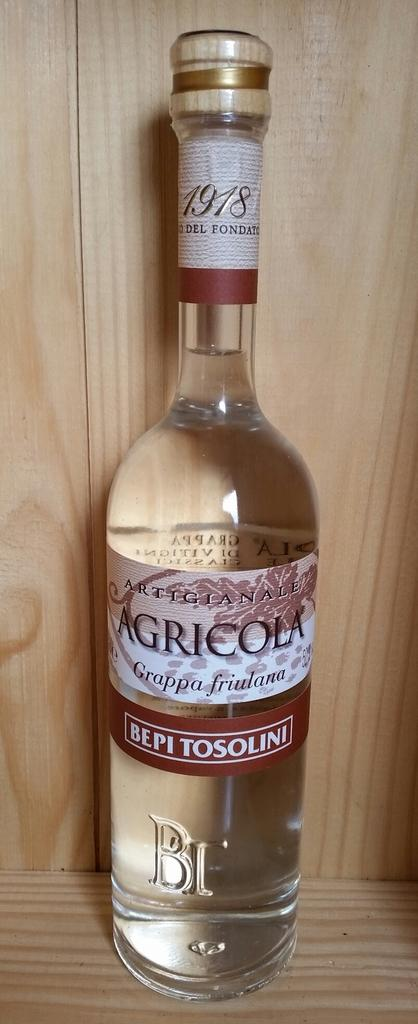<image>
Summarize the visual content of the image. Agricola bottle sits alone on a wooden shelf 